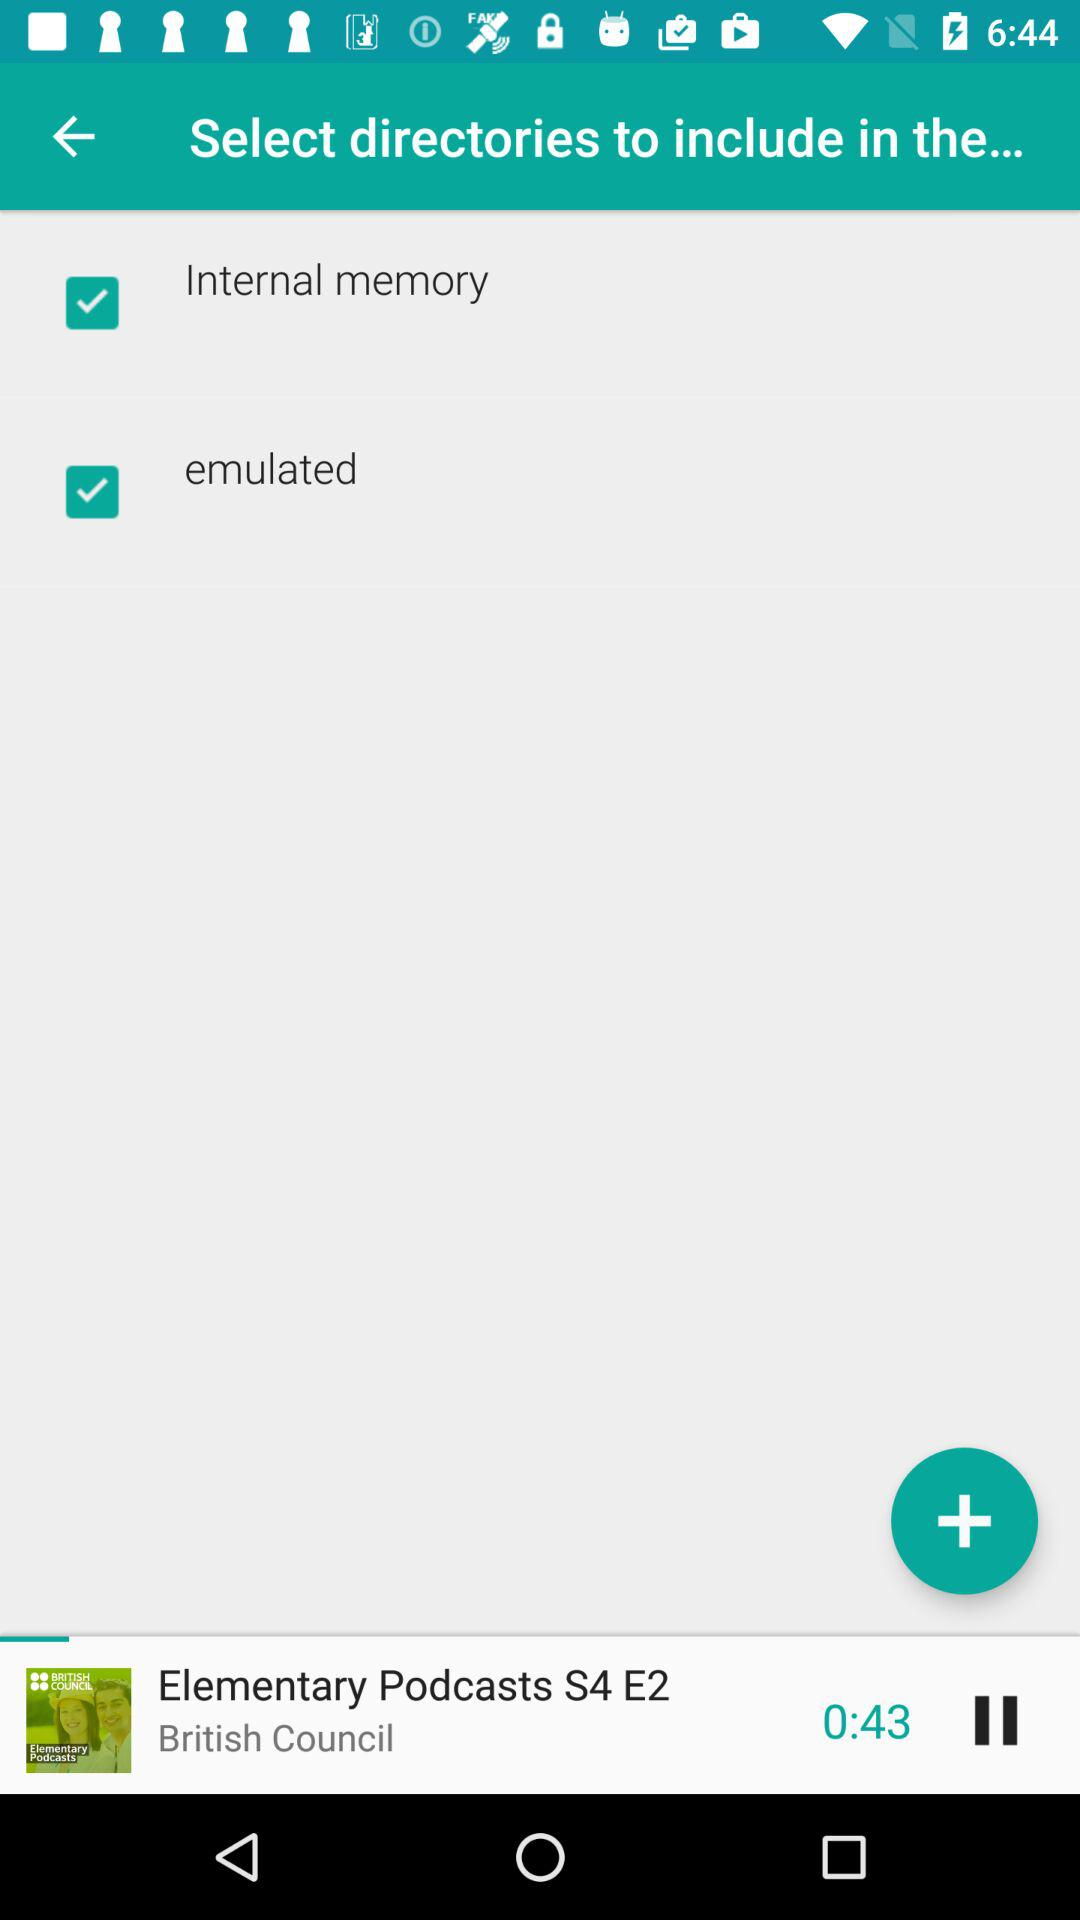What is the elapsed time of the podcast that is currently playing? The elapsed time of the podcast that is currently playing is 43 seconds. 